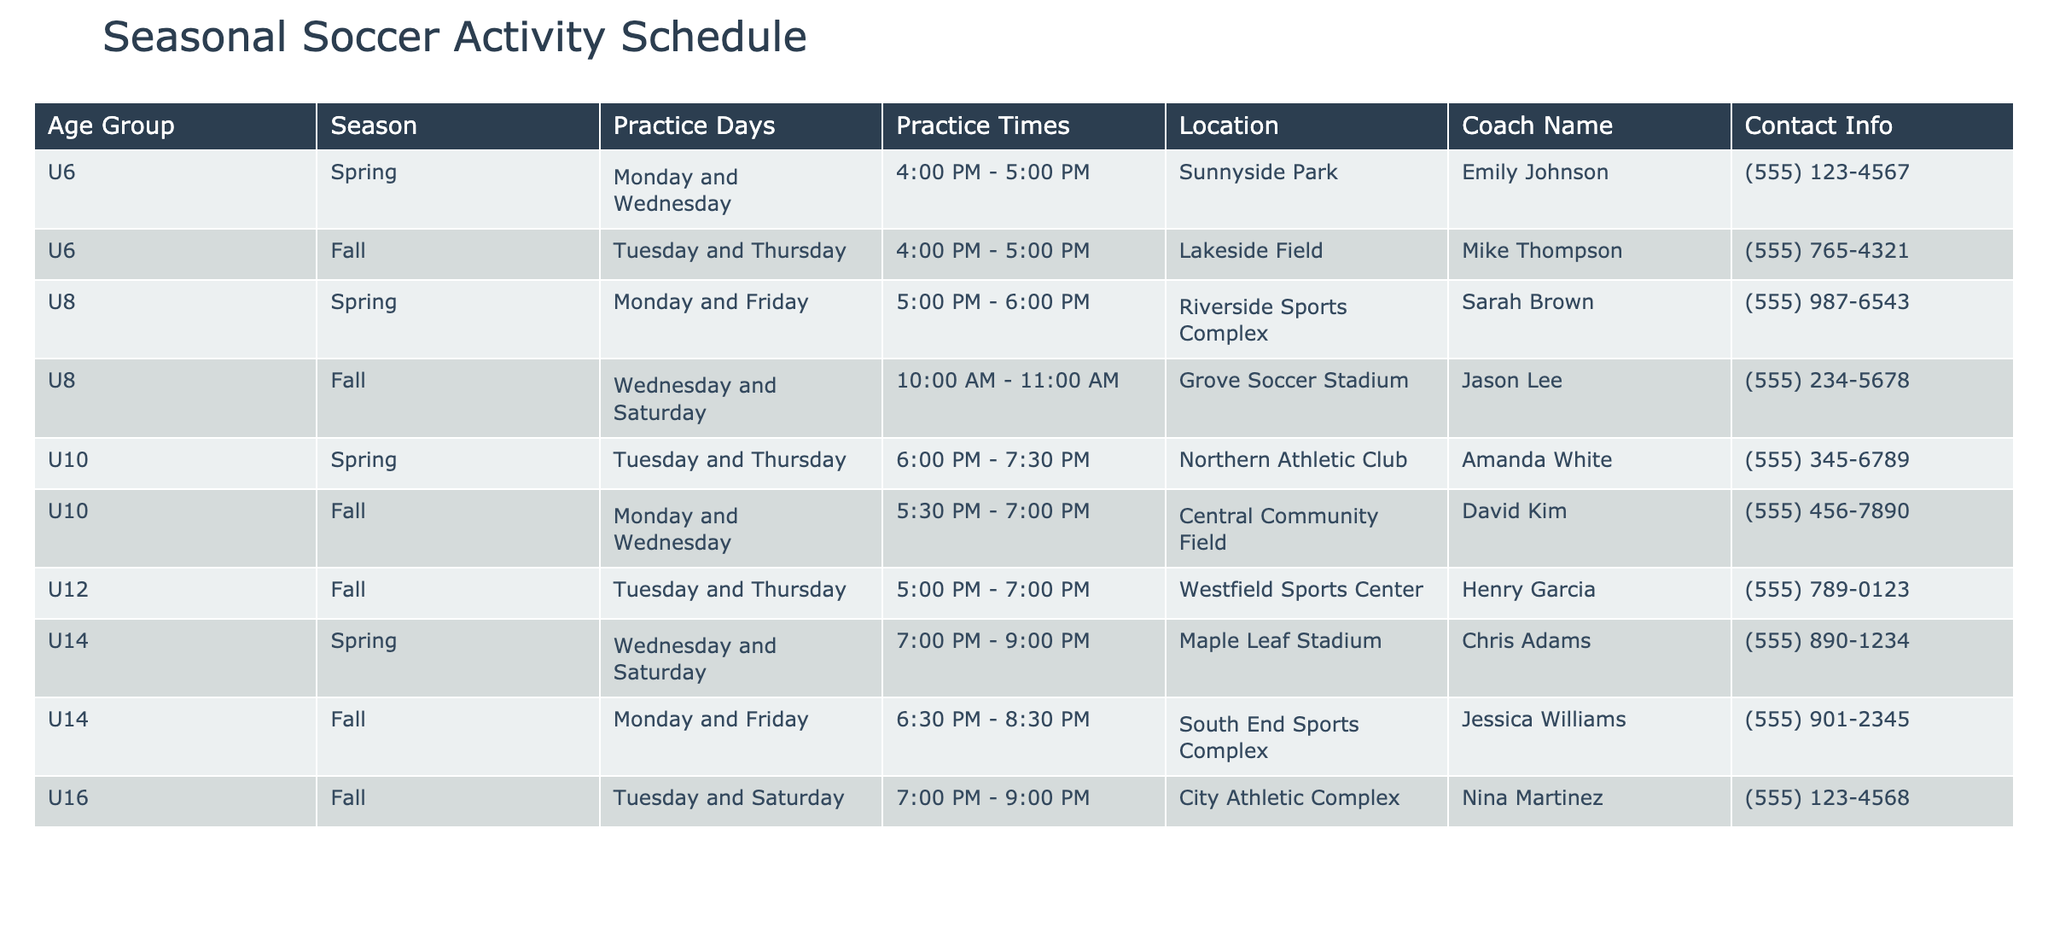What days are U6 soccer practices held in the Spring? According to the table, U6 soccer practices in the Spring are held on Monday and Wednesday.
Answer: Monday and Wednesday Who is the coach for the U10 team in the Fall? The table indicates that the coach for the U10 team in the Fall is David Kim.
Answer: David Kim What time do U12 practices start in the Fall? The U12 practices in the Fall start at 5:00 PM.
Answer: 5:00 PM Is there a team practicing at Lakeside Field? The table shows that the U6 team practices at Lakeside Field in the Fall.
Answer: Yes Which age group has practices on Saturday during the Fall? The table specifies that U8, U14, and U16 age groups have practices on Saturday during the Fall.
Answer: U8, U14, U16 What are the practice times for U8 in the Spring? The U8 team practices in the Spring from 5:00 PM to 6:00 PM.
Answer: 5:00 PM - 6:00 PM How many different locations are used for U14 practices? U14 practices are held at two locations: Maple Leaf Stadium in Spring and South End Sports Complex in Fall, thus there are 2 different locations.
Answer: 2 What’s the total number of teams practicing on Monday? The table shows that U6 and U10 have practices on Monday, so there are 2 teams practicing on that day.
Answer: 2 Which age group practices the latest in the Spring? The U14 team practices the latest in Spring, from 7:00 PM to 9:00 PM.
Answer: U14 What days do U10 players practice in the Spring compared to the Fall? U10 players practice on Tuesday and Thursday in Spring and Monday and Wednesday in Fall. These days differ for each season.
Answer: They practice different days 